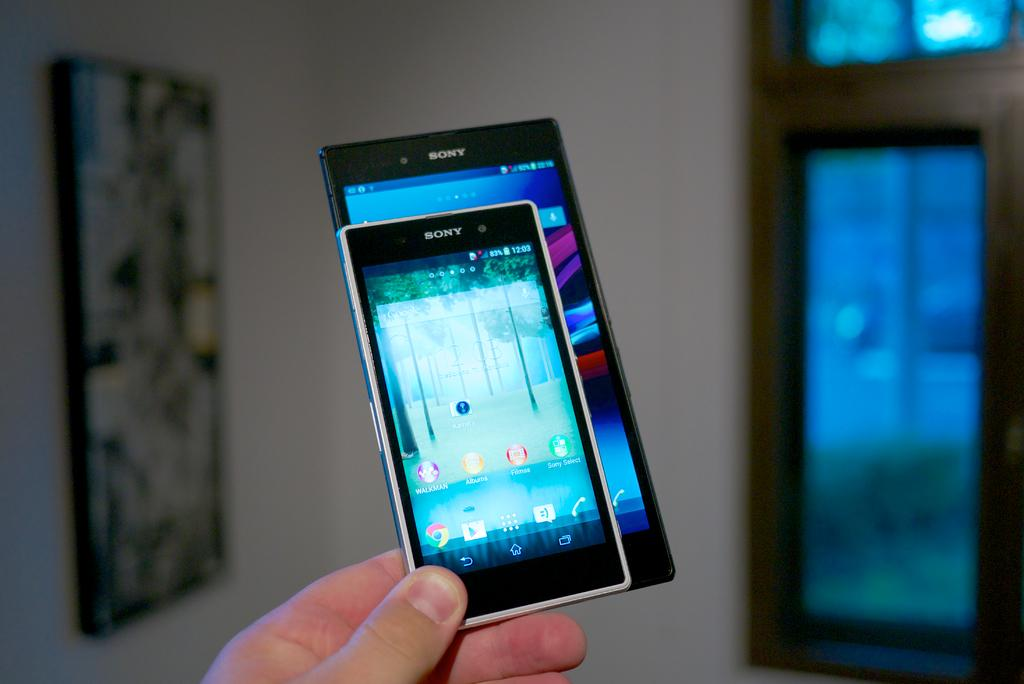Provide a one-sentence caption for the provided image. A comparison in size of two Sony smartphones being held in the fingertips of a person. 